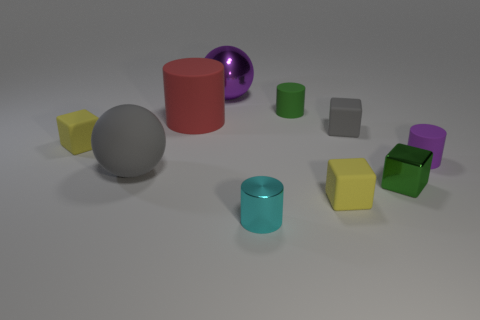Subtract 1 blocks. How many blocks are left? 3 Subtract all cubes. How many objects are left? 6 Add 8 large red matte cylinders. How many large red matte cylinders are left? 9 Add 6 tiny green rubber cylinders. How many tiny green rubber cylinders exist? 7 Subtract 0 cyan blocks. How many objects are left? 10 Subtract all tiny shiny cylinders. Subtract all red cylinders. How many objects are left? 8 